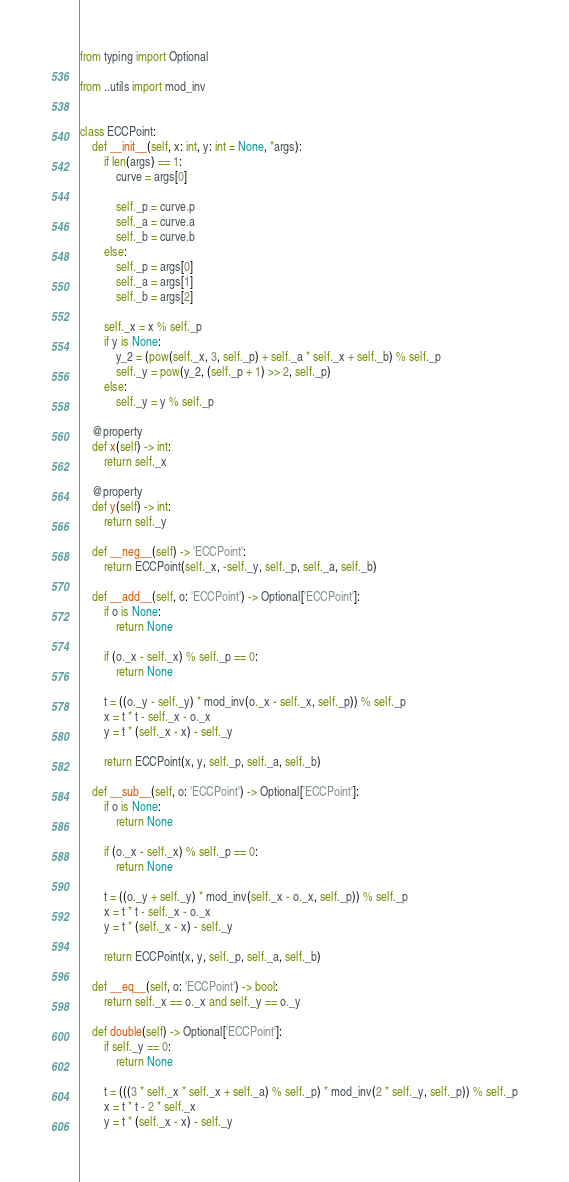Convert code to text. <code><loc_0><loc_0><loc_500><loc_500><_Python_>from typing import Optional

from ..utils import mod_inv


class ECCPoint:
    def __init__(self, x: int, y: int = None, *args):
        if len(args) == 1:
            curve = args[0]

            self._p = curve.p
            self._a = curve.a
            self._b = curve.b
        else:
            self._p = args[0]
            self._a = args[1]
            self._b = args[2]

        self._x = x % self._p
        if y is None:
            y_2 = (pow(self._x, 3, self._p) + self._a * self._x + self._b) % self._p
            self._y = pow(y_2, (self._p + 1) >> 2, self._p)
        else:
            self._y = y % self._p

    @property
    def x(self) -> int:
        return self._x

    @property
    def y(self) -> int:
        return self._y

    def __neg__(self) -> 'ECCPoint':
        return ECCPoint(self._x, -self._y, self._p, self._a, self._b)

    def __add__(self, o: 'ECCPoint') -> Optional['ECCPoint']:
        if o is None:
            return None

        if (o._x - self._x) % self._p == 0:
            return None

        t = ((o._y - self._y) * mod_inv(o._x - self._x, self._p)) % self._p
        x = t * t - self._x - o._x
        y = t * (self._x - x) - self._y

        return ECCPoint(x, y, self._p, self._a, self._b)

    def __sub__(self, o: 'ECCPoint') -> Optional['ECCPoint']:
        if o is None:
            return None

        if (o._x - self._x) % self._p == 0:
            return None

        t = ((o._y + self._y) * mod_inv(self._x - o._x, self._p)) % self._p
        x = t * t - self._x - o._x
        y = t * (self._x - x) - self._y

        return ECCPoint(x, y, self._p, self._a, self._b)

    def __eq__(self, o: 'ECCPoint') -> bool:
        return self._x == o._x and self._y == o._y

    def double(self) -> Optional['ECCPoint']:
        if self._y == 0:
            return None

        t = (((3 * self._x * self._x + self._a) % self._p) * mod_inv(2 * self._y, self._p)) % self._p
        x = t * t - 2 * self._x
        y = t * (self._x - x) - self._y
</code> 